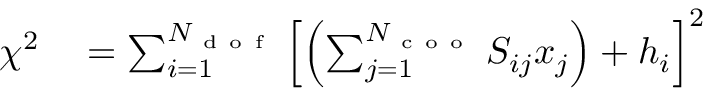Convert formula to latex. <formula><loc_0><loc_0><loc_500><loc_500>\begin{array} { r l } { \chi ^ { 2 } } & = \sum _ { i = 1 } ^ { N _ { d o f } } \left [ \left ( \sum _ { j = 1 } ^ { N _ { c o o } } S _ { i j } x _ { j } \right ) + h _ { i } \right ] ^ { 2 } } \end{array}</formula> 